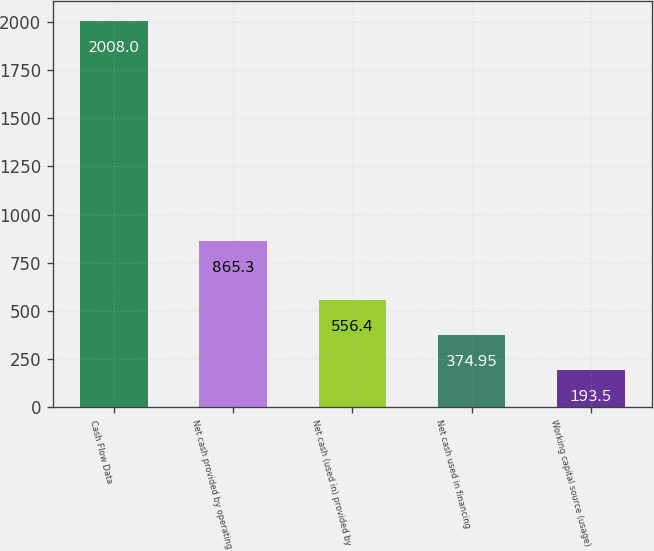<chart> <loc_0><loc_0><loc_500><loc_500><bar_chart><fcel>Cash Flow Data<fcel>Net cash provided by operating<fcel>Net cash (used in) provided by<fcel>Net cash used in financing<fcel>Working capital source (usage)<nl><fcel>2008<fcel>865.3<fcel>556.4<fcel>374.95<fcel>193.5<nl></chart> 